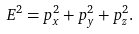Convert formula to latex. <formula><loc_0><loc_0><loc_500><loc_500>E ^ { 2 } = p _ { x } ^ { 2 } + p _ { y } ^ { 2 } + p _ { z } ^ { 2 } .</formula> 